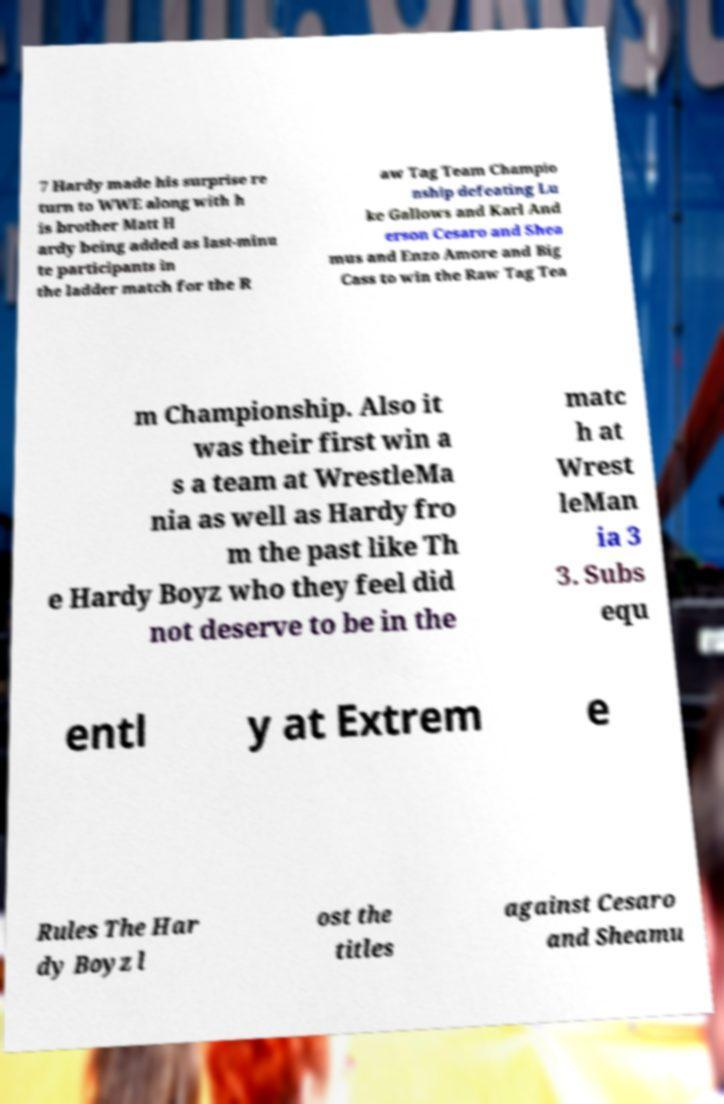Can you accurately transcribe the text from the provided image for me? 7 Hardy made his surprise re turn to WWE along with h is brother Matt H ardy being added as last-minu te participants in the ladder match for the R aw Tag Team Champio nship defeating Lu ke Gallows and Karl And erson Cesaro and Shea mus and Enzo Amore and Big Cass to win the Raw Tag Tea m Championship. Also it was their first win a s a team at WrestleMa nia as well as Hardy fro m the past like Th e Hardy Boyz who they feel did not deserve to be in the matc h at Wrest leMan ia 3 3. Subs equ entl y at Extrem e Rules The Har dy Boyz l ost the titles against Cesaro and Sheamu 